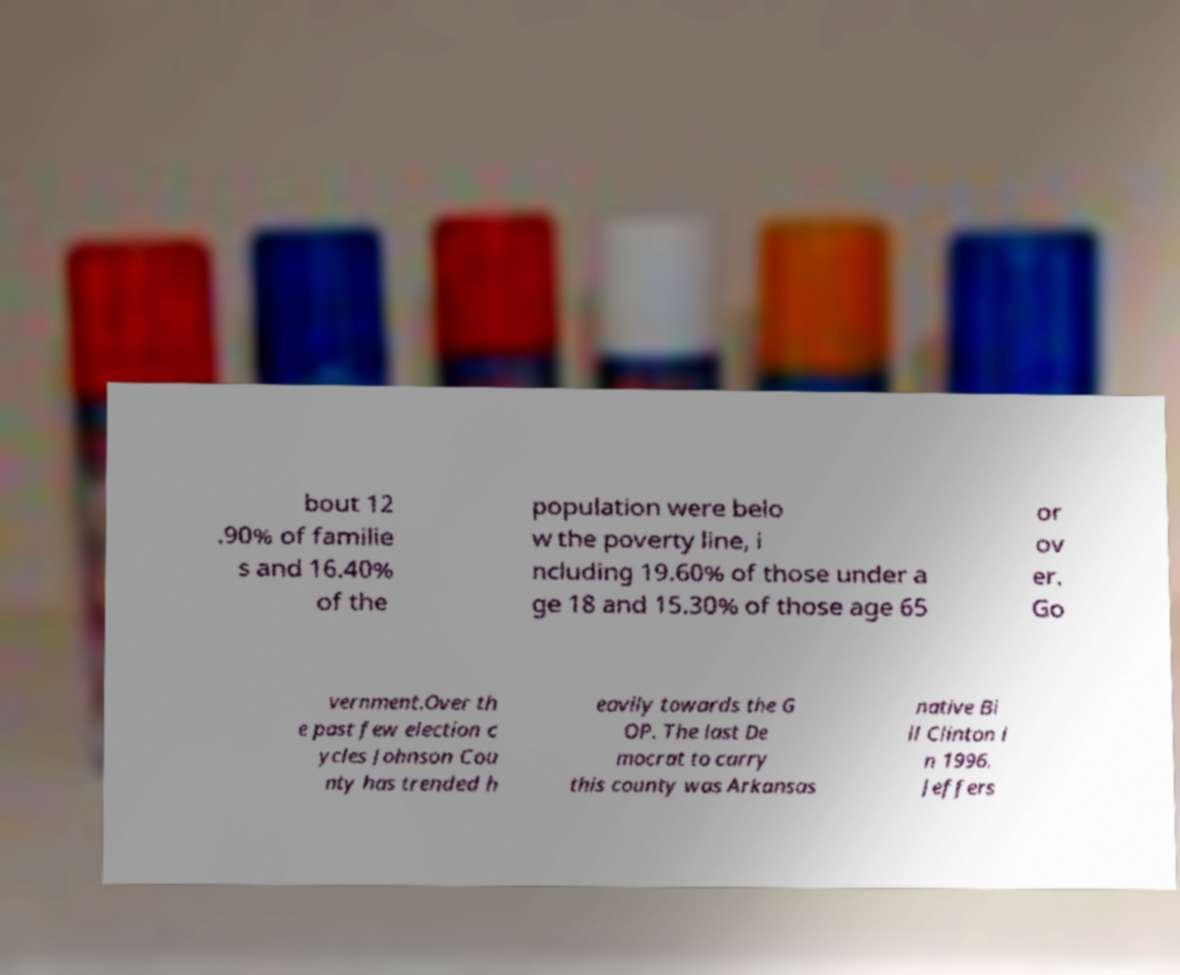Please read and relay the text visible in this image. What does it say? bout 12 .90% of familie s and 16.40% of the population were belo w the poverty line, i ncluding 19.60% of those under a ge 18 and 15.30% of those age 65 or ov er. Go vernment.Over th e past few election c ycles Johnson Cou nty has trended h eavily towards the G OP. The last De mocrat to carry this county was Arkansas native Bi ll Clinton i n 1996. Jeffers 